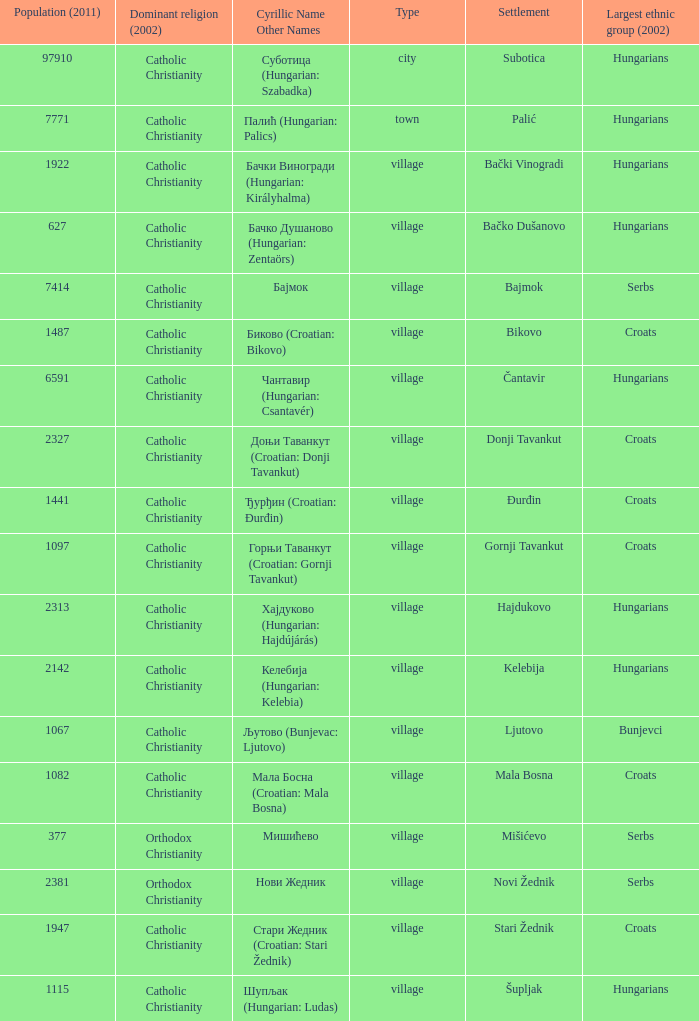What are the cyrillic and other names of the settlement whose population is 6591? Чантавир (Hungarian: Csantavér). 